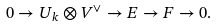Convert formula to latex. <formula><loc_0><loc_0><loc_500><loc_500>0 \to U _ { k } \otimes V ^ { \vee } \to E \to F \to 0 .</formula> 